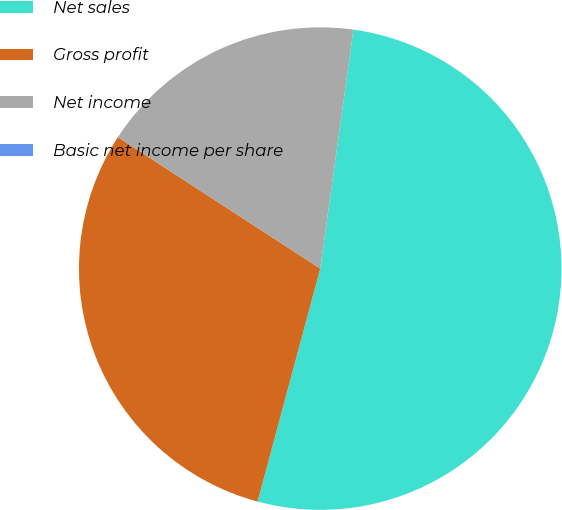Convert chart. <chart><loc_0><loc_0><loc_500><loc_500><pie_chart><fcel>Net sales<fcel>Gross profit<fcel>Net income<fcel>Basic net income per share<nl><fcel>51.99%<fcel>29.99%<fcel>18.03%<fcel>0.0%<nl></chart> 